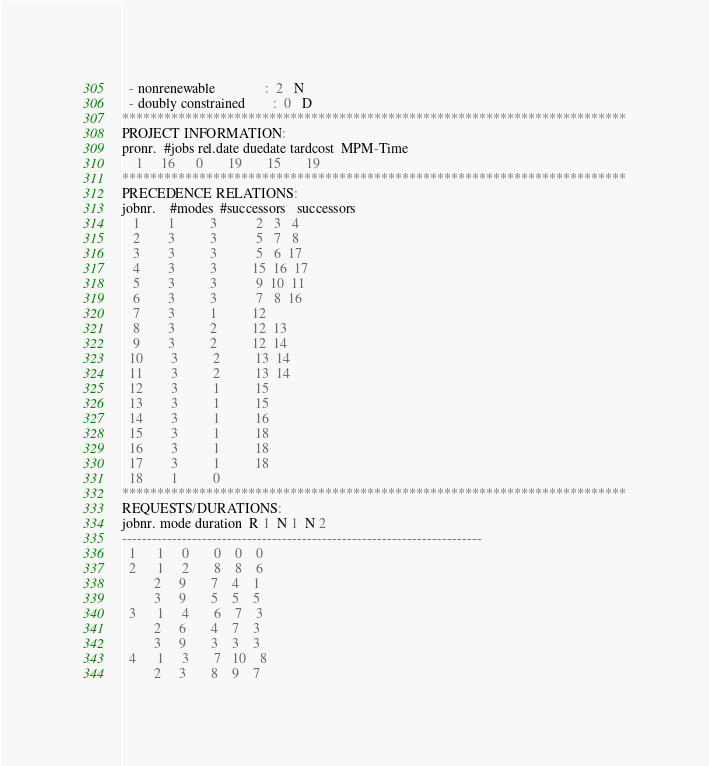Convert code to text. <code><loc_0><loc_0><loc_500><loc_500><_ObjectiveC_>  - nonrenewable              :  2   N
  - doubly constrained        :  0   D
************************************************************************
PROJECT INFORMATION:
pronr.  #jobs rel.date duedate tardcost  MPM-Time
    1     16      0       19       15       19
************************************************************************
PRECEDENCE RELATIONS:
jobnr.    #modes  #successors   successors
   1        1          3           2   3   4
   2        3          3           5   7   8
   3        3          3           5   6  17
   4        3          3          15  16  17
   5        3          3           9  10  11
   6        3          3           7   8  16
   7        3          1          12
   8        3          2          12  13
   9        3          2          12  14
  10        3          2          13  14
  11        3          2          13  14
  12        3          1          15
  13        3          1          15
  14        3          1          16
  15        3          1          18
  16        3          1          18
  17        3          1          18
  18        1          0        
************************************************************************
REQUESTS/DURATIONS:
jobnr. mode duration  R 1  N 1  N 2
------------------------------------------------------------------------
  1      1     0       0    0    0
  2      1     2       8    8    6
         2     9       7    4    1
         3     9       5    5    5
  3      1     4       6    7    3
         2     6       4    7    3
         3     9       3    3    3
  4      1     3       7   10    8
         2     3       8    9    7</code> 